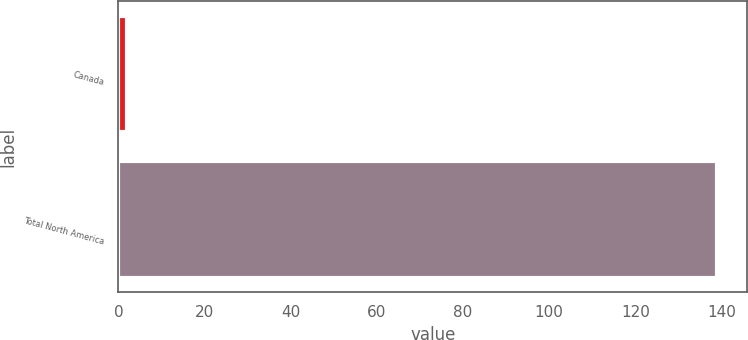Convert chart to OTSL. <chart><loc_0><loc_0><loc_500><loc_500><bar_chart><fcel>Canada<fcel>Total North America<nl><fcel>2<fcel>139<nl></chart> 